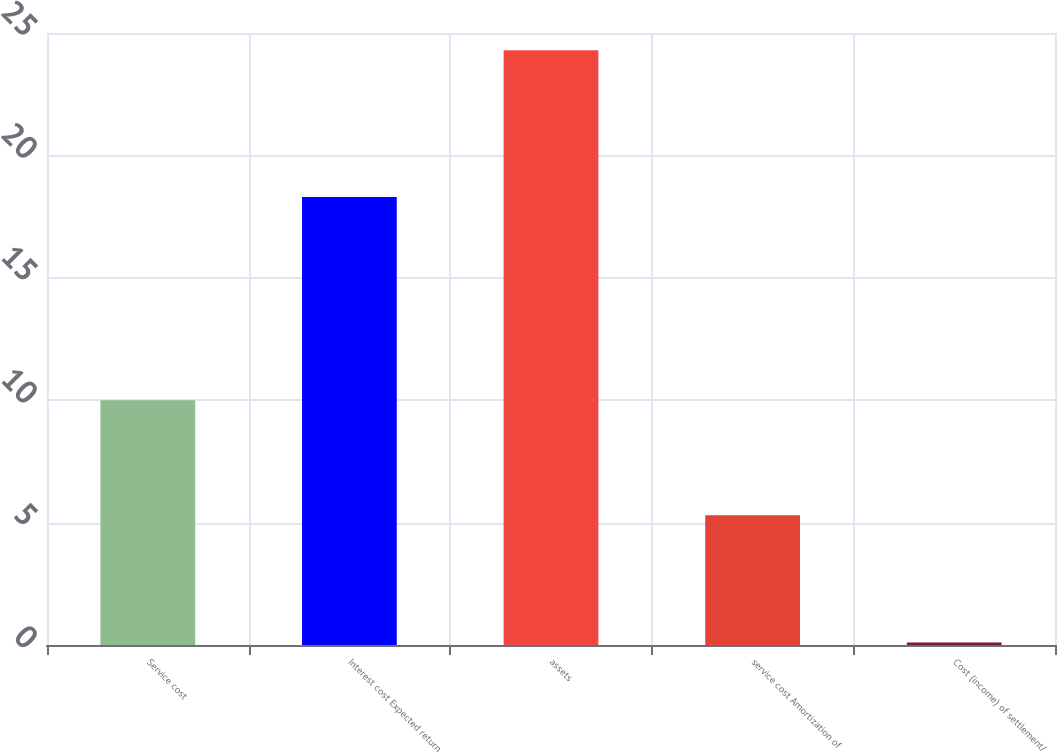<chart> <loc_0><loc_0><loc_500><loc_500><bar_chart><fcel>Service cost<fcel>Interest cost Expected return<fcel>assets<fcel>service cost Amortization of<fcel>Cost (income) of settlement/<nl><fcel>10<fcel>18.3<fcel>24.3<fcel>5.3<fcel>0.1<nl></chart> 